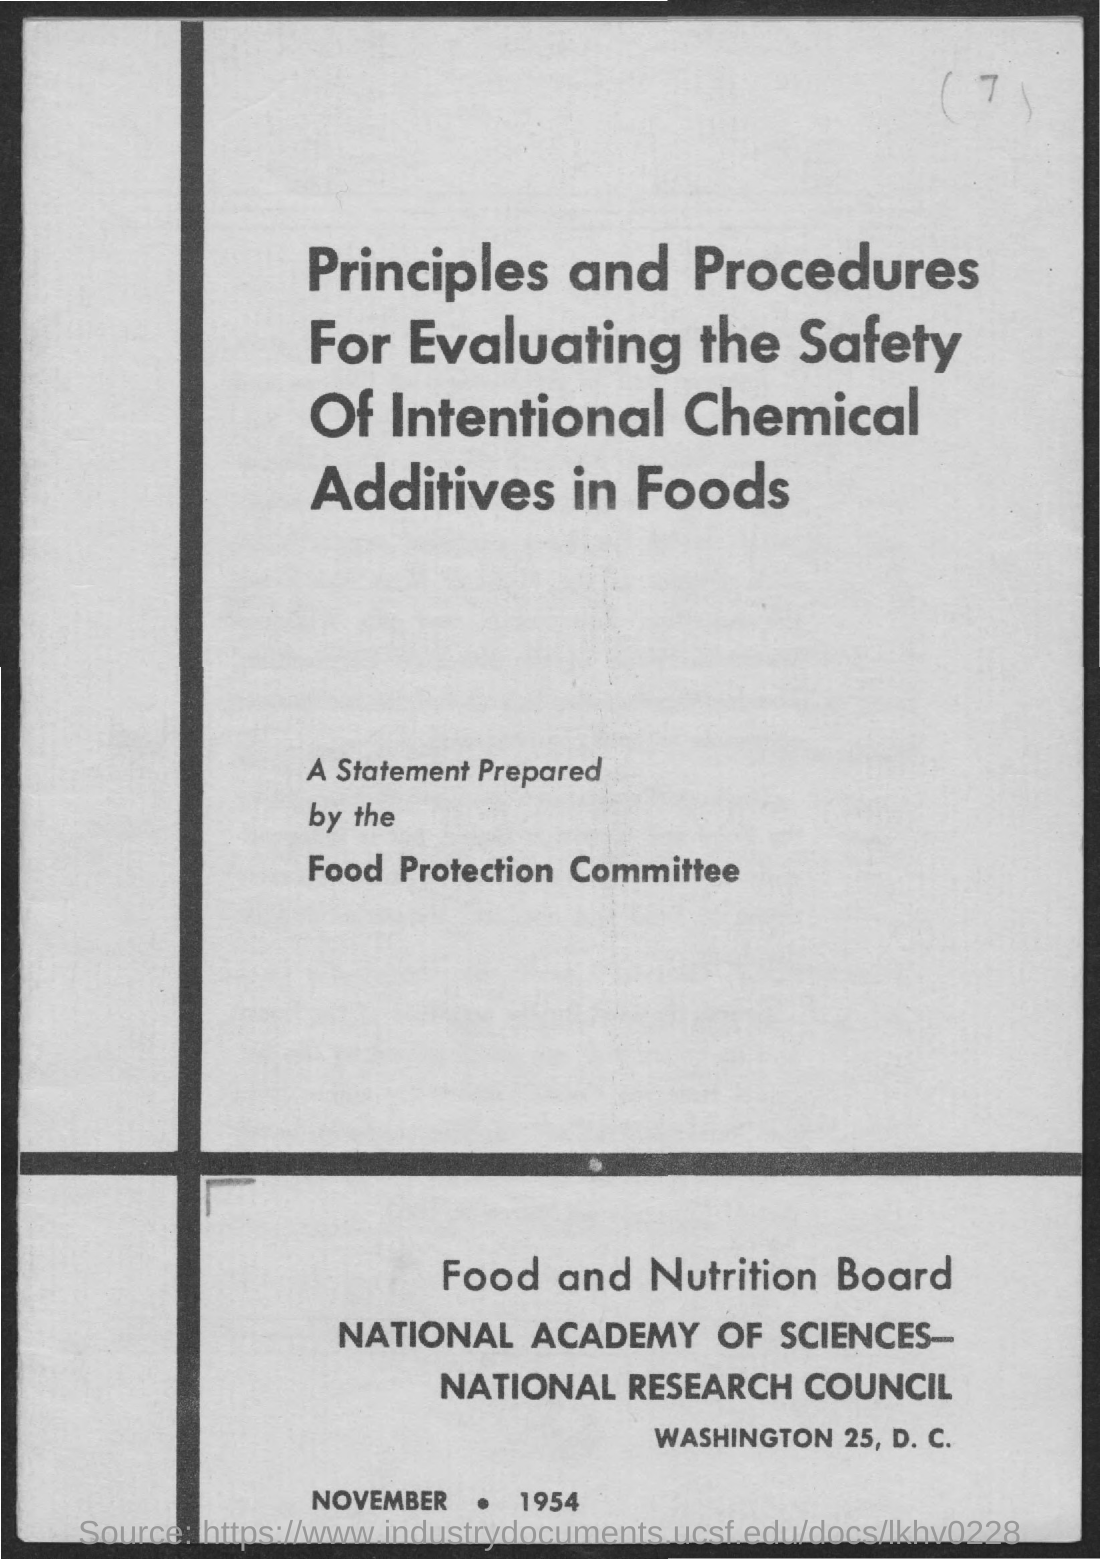Identify some key points in this picture. The document mentions that the date is November 1954. 